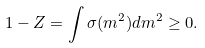<formula> <loc_0><loc_0><loc_500><loc_500>1 - Z = \int \sigma ( m ^ { 2 } ) d m ^ { 2 } \geq 0 .</formula> 